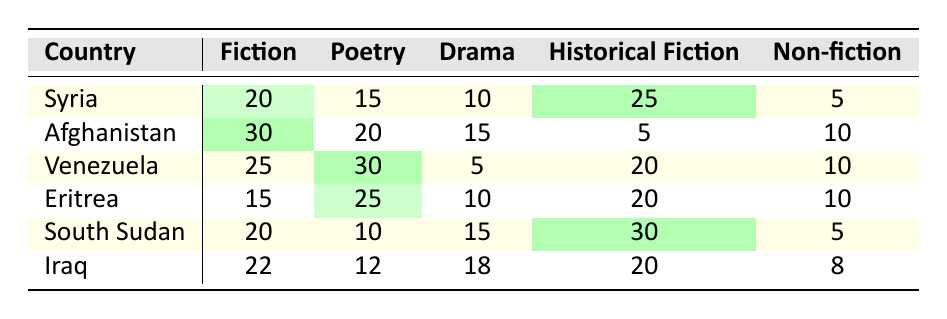What is the highest preference for Historical Fiction among the countries listed? Looking at the "Historical Fiction" column, South Sudan shows the highest preference with a score of 30.
Answer: 30 Which country has the lowest preference for Non-fiction? In the "Non-fiction" column, Syria has the lowest preference with a score of 5.
Answer: 5 What is the average preference for Fiction across all countries? To calculate the average, sum the Fiction values for all countries: 20 + 30 + 25 + 15 + 20 + 22 = 132, then divide by 6 (the number of countries): 132/6 = 22.
Answer: 22 Which country prefers Poetry more, Syria or Iraq? Comparing the "Poetry" values of Syria (15) and Iraq (12), Syria has a higher preference for Poetry.
Answer: Syria Is the preference for Drama higher in Venezuela than in Afghanistan? Venezuela has a score of 5 for Drama, while Afghanistan has a score of 15, thus Afghanistan has a higher preference for Drama.
Answer: No What is the total preference for Fiction and Poetry combined for Eritrea? For Eritrea, Fiction is 15 and Poetry is 25. Adding these gives 15 + 25 = 40.
Answer: 40 Which genre has the highest overall preference across all countries? Examining the highest values in each genre: Fiction (30), Poetry (30), Drama (18), Historical Fiction (30), and Non-fiction (10). The highest repeated score is 30 for Fiction, Poetry, and Historical Fiction.
Answer: 30 What is the difference in preference for Historical Fiction between South Sudan and Syria? South Sudan has a preference of 30 and Syria has a preference of 25 for Historical Fiction. The difference is 30 - 25 = 5.
Answer: 5 